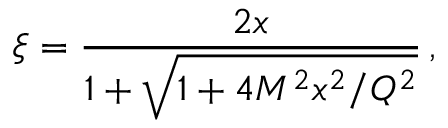Convert formula to latex. <formula><loc_0><loc_0><loc_500><loc_500>\xi = \frac { 2 x } { 1 + \sqrt { 1 + 4 M ^ { 2 } x ^ { 2 } / Q ^ { 2 } } } \, ,</formula> 